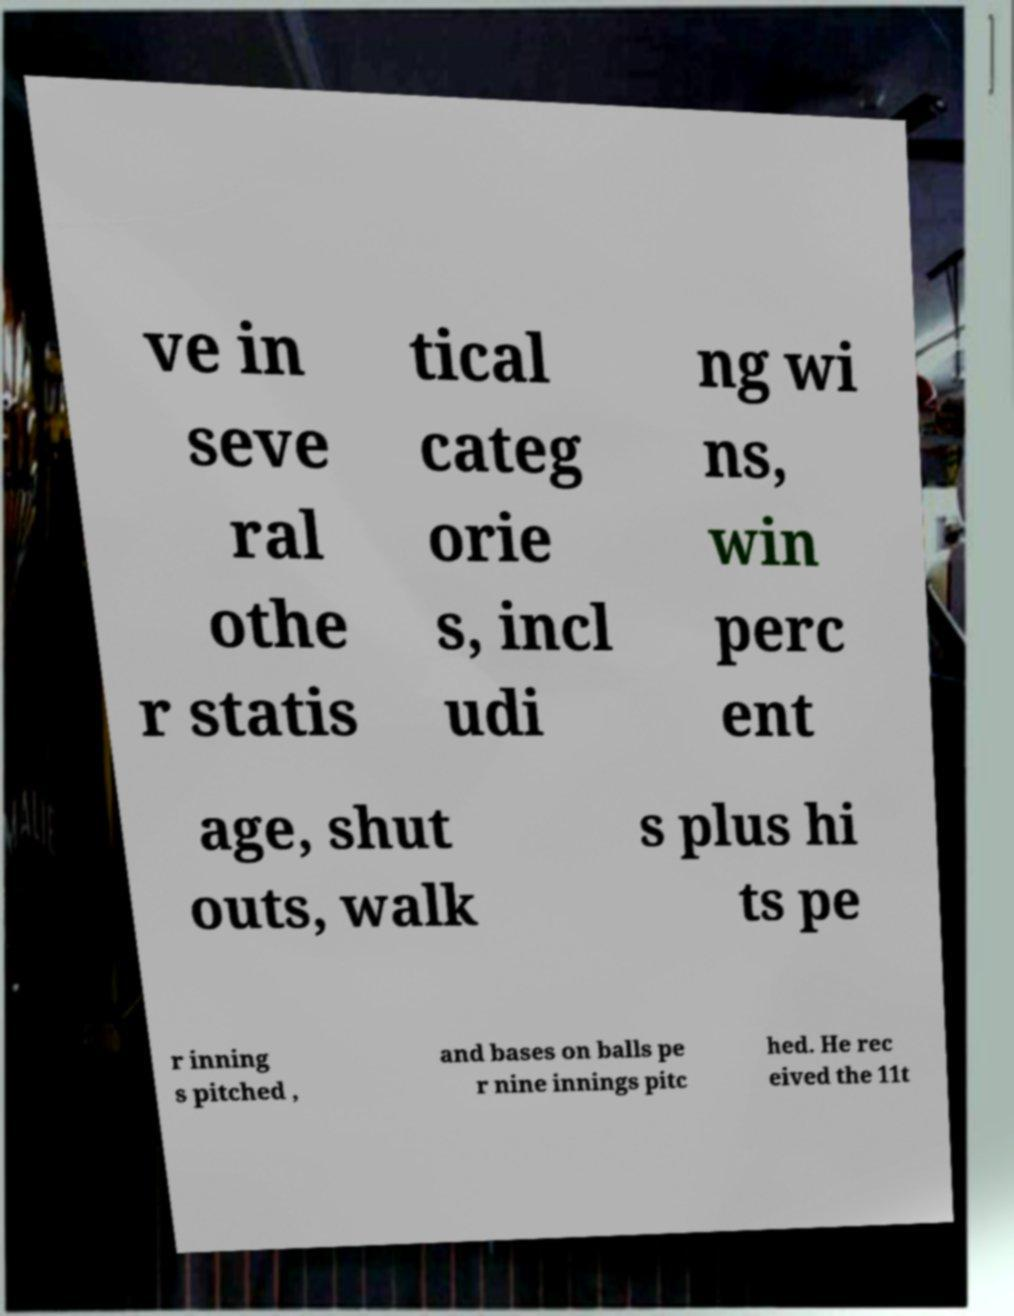Could you extract and type out the text from this image? ve in seve ral othe r statis tical categ orie s, incl udi ng wi ns, win perc ent age, shut outs, walk s plus hi ts pe r inning s pitched , and bases on balls pe r nine innings pitc hed. He rec eived the 11t 